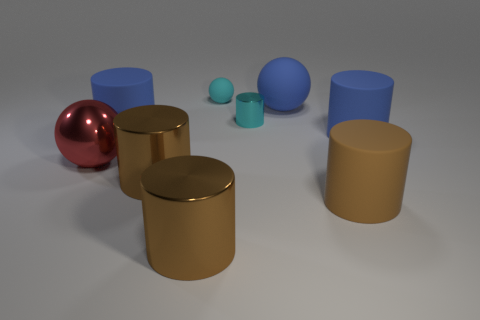Subtract all blue cubes. How many brown cylinders are left? 3 Subtract 3 cylinders. How many cylinders are left? 3 Subtract all tiny cyan cylinders. How many cylinders are left? 5 Subtract all blue cylinders. How many cylinders are left? 4 Subtract all purple cylinders. Subtract all blue balls. How many cylinders are left? 6 Add 1 metallic cylinders. How many objects exist? 10 Subtract all cylinders. How many objects are left? 3 Add 6 blue matte spheres. How many blue matte spheres are left? 7 Add 1 yellow objects. How many yellow objects exist? 1 Subtract 1 blue cylinders. How many objects are left? 8 